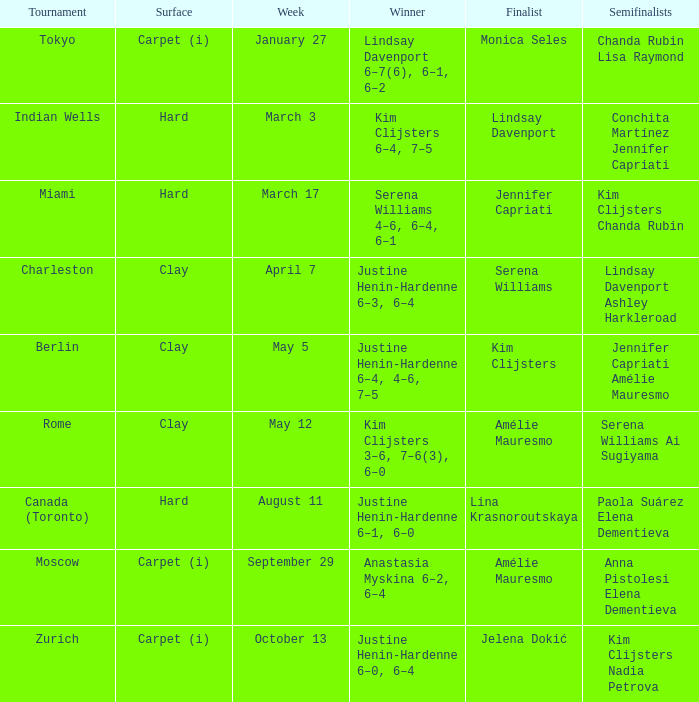I'm looking to parse the entire table for insights. Could you assist me with that? {'header': ['Tournament', 'Surface', 'Week', 'Winner', 'Finalist', 'Semifinalists'], 'rows': [['Tokyo', 'Carpet (i)', 'January 27', 'Lindsay Davenport 6–7(6), 6–1, 6–2', 'Monica Seles', 'Chanda Rubin Lisa Raymond'], ['Indian Wells', 'Hard', 'March 3', 'Kim Clijsters 6–4, 7–5', 'Lindsay Davenport', 'Conchita Martínez Jennifer Capriati'], ['Miami', 'Hard', 'March 17', 'Serena Williams 4–6, 6–4, 6–1', 'Jennifer Capriati', 'Kim Clijsters Chanda Rubin'], ['Charleston', 'Clay', 'April 7', 'Justine Henin-Hardenne 6–3, 6–4', 'Serena Williams', 'Lindsay Davenport Ashley Harkleroad'], ['Berlin', 'Clay', 'May 5', 'Justine Henin-Hardenne 6–4, 4–6, 7–5', 'Kim Clijsters', 'Jennifer Capriati Amélie Mauresmo'], ['Rome', 'Clay', 'May 12', 'Kim Clijsters 3–6, 7–6(3), 6–0', 'Amélie Mauresmo', 'Serena Williams Ai Sugiyama'], ['Canada (Toronto)', 'Hard', 'August 11', 'Justine Henin-Hardenne 6–1, 6–0', 'Lina Krasnoroutskaya', 'Paola Suárez Elena Dementieva'], ['Moscow', 'Carpet (i)', 'September 29', 'Anastasia Myskina 6–2, 6–4', 'Amélie Mauresmo', 'Anna Pistolesi Elena Dementieva'], ['Zurich', 'Carpet (i)', 'October 13', 'Justine Henin-Hardenne 6–0, 6–4', 'Jelena Dokić', 'Kim Clijsters Nadia Petrova']]} Who was the finalist in Miami? Jennifer Capriati. 